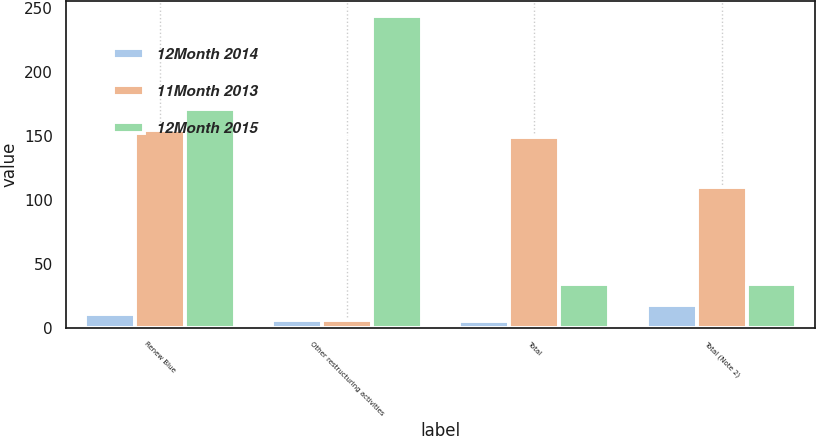Convert chart to OTSL. <chart><loc_0><loc_0><loc_500><loc_500><stacked_bar_chart><ecel><fcel>Renew Blue<fcel>Other restructuring activities<fcel>Total<fcel>Total (Note 2)<nl><fcel>12Month 2014<fcel>11<fcel>6<fcel>5<fcel>18<nl><fcel>11Month 2013<fcel>155<fcel>6<fcel>149<fcel>110<nl><fcel>12Month 2015<fcel>171<fcel>244<fcel>34<fcel>34<nl></chart> 